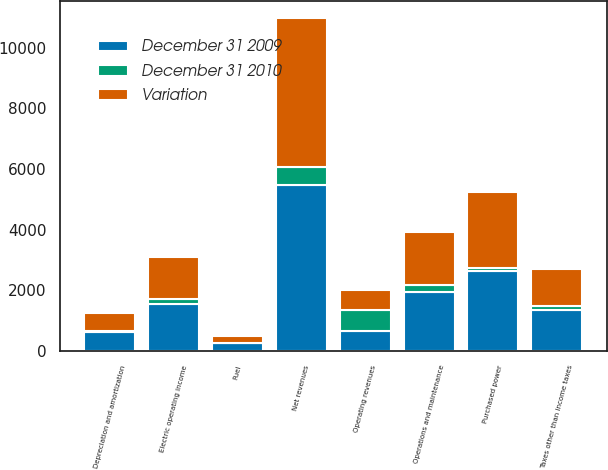Convert chart to OTSL. <chart><loc_0><loc_0><loc_500><loc_500><stacked_bar_chart><ecel><fcel>Operating revenues<fcel>Purchased power<fcel>Fuel<fcel>Net revenues<fcel>Operations and maintenance<fcel>Depreciation and amortization<fcel>Taxes other than income taxes<fcel>Electric operating income<nl><fcel>December 31 2009<fcel>662.5<fcel>2629<fcel>256<fcel>5491<fcel>1963<fcel>623<fcel>1356<fcel>1549<nl><fcel>Variation<fcel>662.5<fcel>2529<fcel>247<fcel>4898<fcel>1734<fcel>587<fcel>1209<fcel>1368<nl><fcel>December 31 2010<fcel>702<fcel>100<fcel>9<fcel>593<fcel>229<fcel>36<fcel>147<fcel>181<nl></chart> 